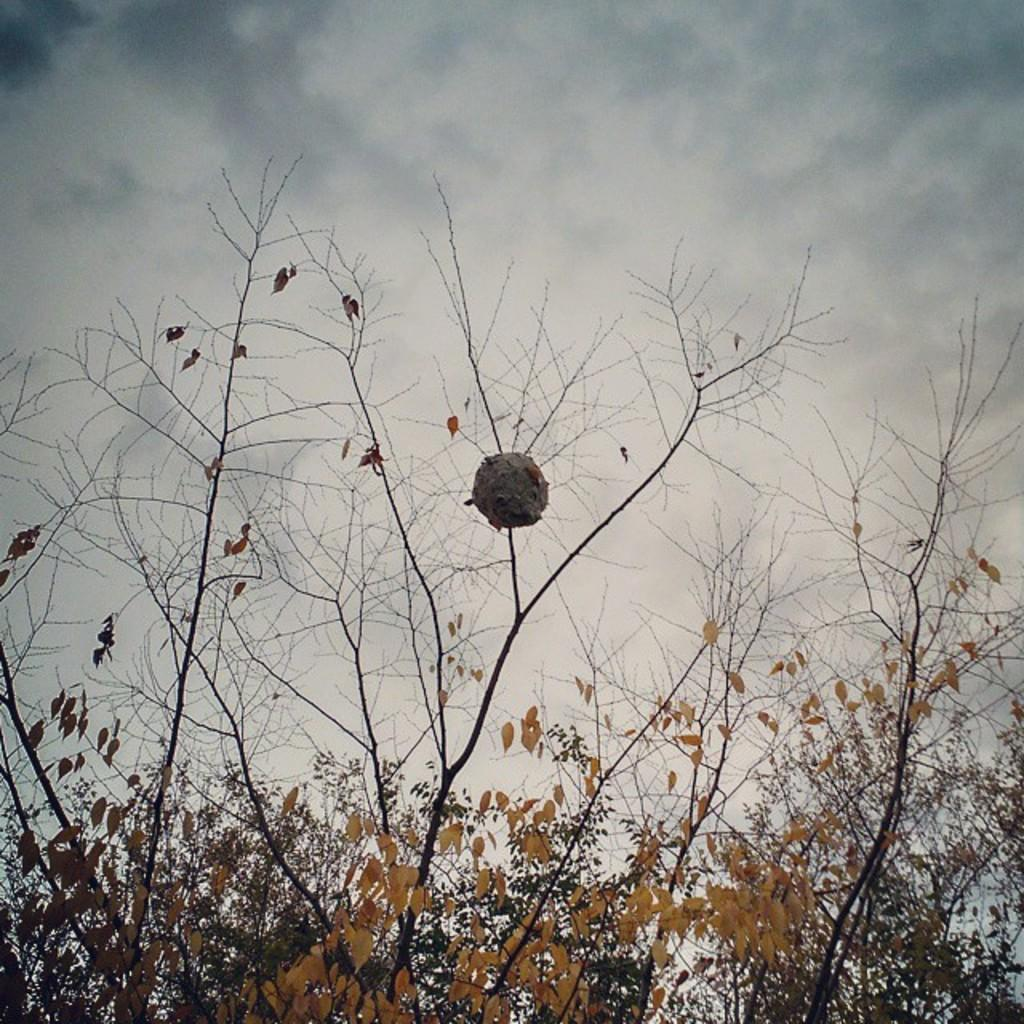What type of vegetation can be seen in the image? There are trees in the image. What is visible at the top of the image? The sky is visible at the top of the image. What can be observed in the sky? There are clouds in the sky. Can you tell me how many deer are visible in the image? There are no deer present in the image; it only features trees and clouds in the sky. Is there a man coaching a team in the image? There is no man or team present in the image; it only features trees and clouds in the sky. 